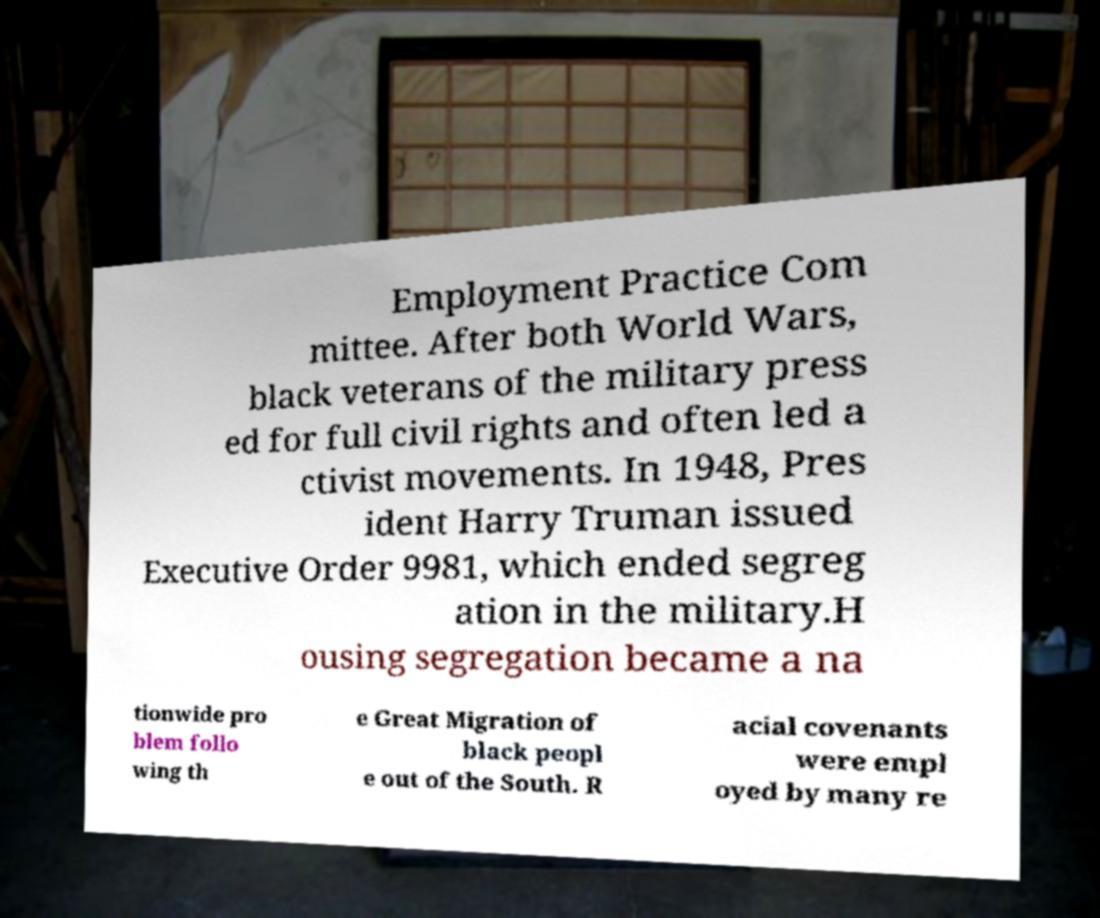Could you assist in decoding the text presented in this image and type it out clearly? Employment Practice Com mittee. After both World Wars, black veterans of the military press ed for full civil rights and often led a ctivist movements. In 1948, Pres ident Harry Truman issued Executive Order 9981, which ended segreg ation in the military.H ousing segregation became a na tionwide pro blem follo wing th e Great Migration of black peopl e out of the South. R acial covenants were empl oyed by many re 